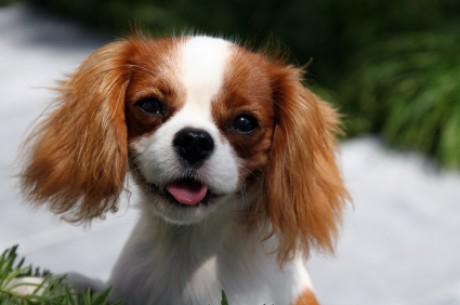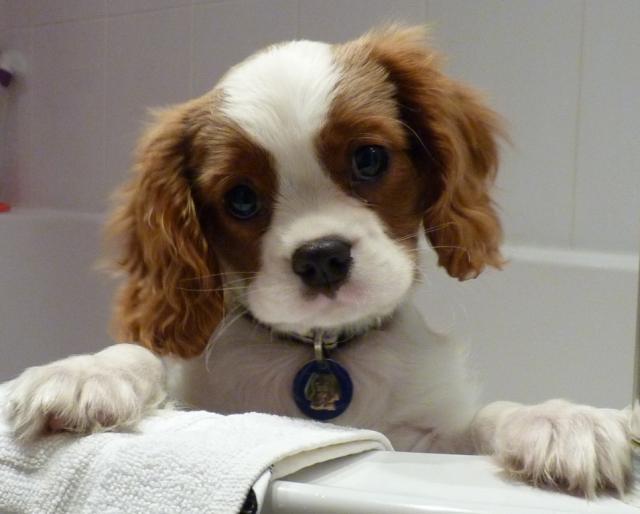The first image is the image on the left, the second image is the image on the right. Examine the images to the left and right. Is the description "All images contain only one dog." accurate? Answer yes or no. Yes. 